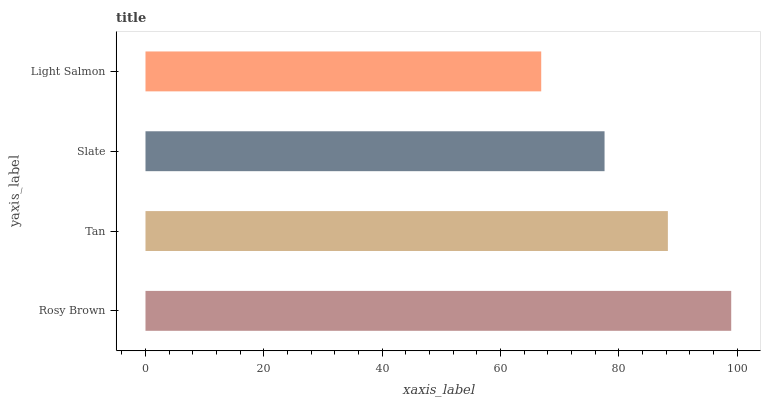Is Light Salmon the minimum?
Answer yes or no. Yes. Is Rosy Brown the maximum?
Answer yes or no. Yes. Is Tan the minimum?
Answer yes or no. No. Is Tan the maximum?
Answer yes or no. No. Is Rosy Brown greater than Tan?
Answer yes or no. Yes. Is Tan less than Rosy Brown?
Answer yes or no. Yes. Is Tan greater than Rosy Brown?
Answer yes or no. No. Is Rosy Brown less than Tan?
Answer yes or no. No. Is Tan the high median?
Answer yes or no. Yes. Is Slate the low median?
Answer yes or no. Yes. Is Rosy Brown the high median?
Answer yes or no. No. Is Light Salmon the low median?
Answer yes or no. No. 